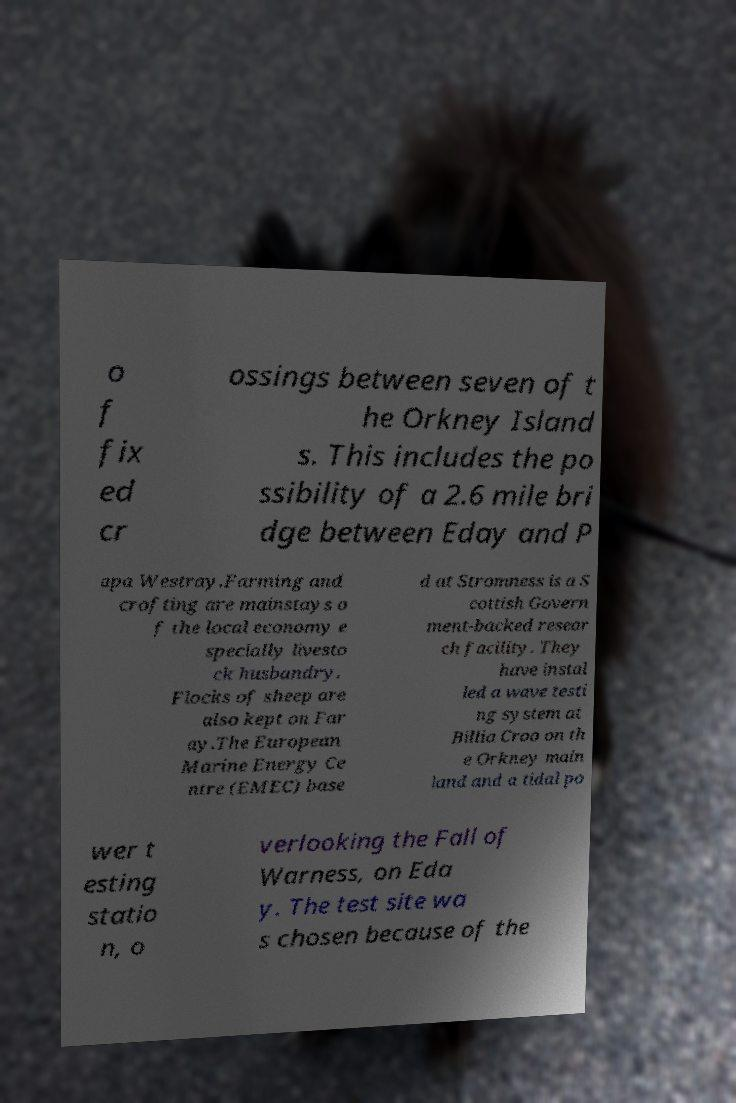Can you read and provide the text displayed in the image?This photo seems to have some interesting text. Can you extract and type it out for me? o f fix ed cr ossings between seven of t he Orkney Island s. This includes the po ssibility of a 2.6 mile bri dge between Eday and P apa Westray.Farming and crofting are mainstays o f the local economy e specially livesto ck husbandry. Flocks of sheep are also kept on Far ay.The European Marine Energy Ce ntre (EMEC) base d at Stromness is a S cottish Govern ment-backed resear ch facility. They have instal led a wave testi ng system at Billia Croo on th e Orkney main land and a tidal po wer t esting statio n, o verlooking the Fall of Warness, on Eda y. The test site wa s chosen because of the 